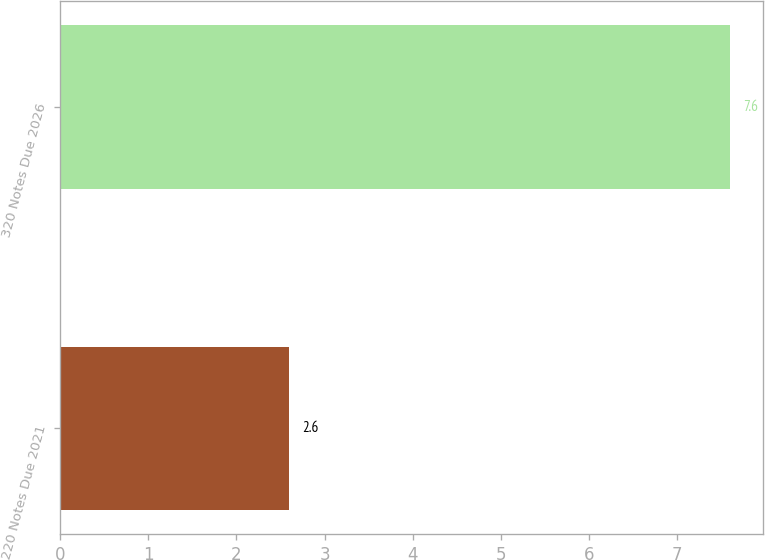Convert chart to OTSL. <chart><loc_0><loc_0><loc_500><loc_500><bar_chart><fcel>220 Notes Due 2021<fcel>320 Notes Due 2026<nl><fcel>2.6<fcel>7.6<nl></chart> 